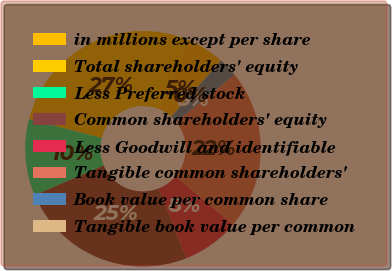Convert chart to OTSL. <chart><loc_0><loc_0><loc_500><loc_500><pie_chart><fcel>in millions except per share<fcel>Total shareholders' equity<fcel>Less Preferred stock<fcel>Common shareholders' equity<fcel>Less Goodwill and identifiable<fcel>Tangible common shareholders'<fcel>Book value per common share<fcel>Tangible book value per common<nl><fcel>5.27%<fcel>27.16%<fcel>10.49%<fcel>24.55%<fcel>7.88%<fcel>21.94%<fcel>2.66%<fcel>0.05%<nl></chart> 